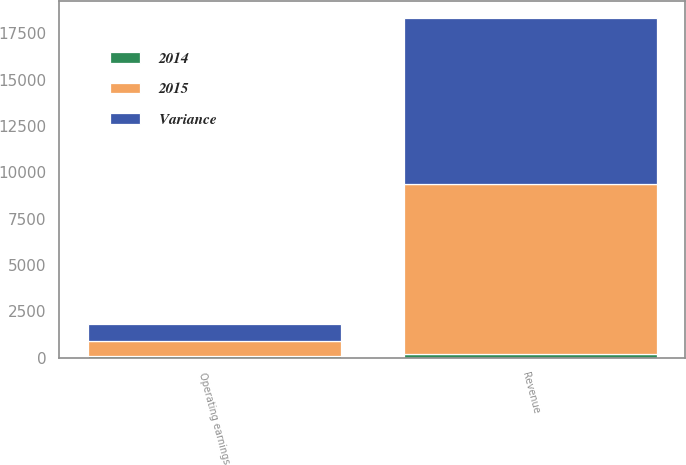<chart> <loc_0><loc_0><loc_500><loc_500><stacked_bar_chart><ecel><fcel>Revenue<fcel>Operating earnings<nl><fcel>Variance<fcel>8965<fcel>903<nl><fcel>2015<fcel>9159<fcel>785<nl><fcel>2014<fcel>194<fcel>118<nl></chart> 